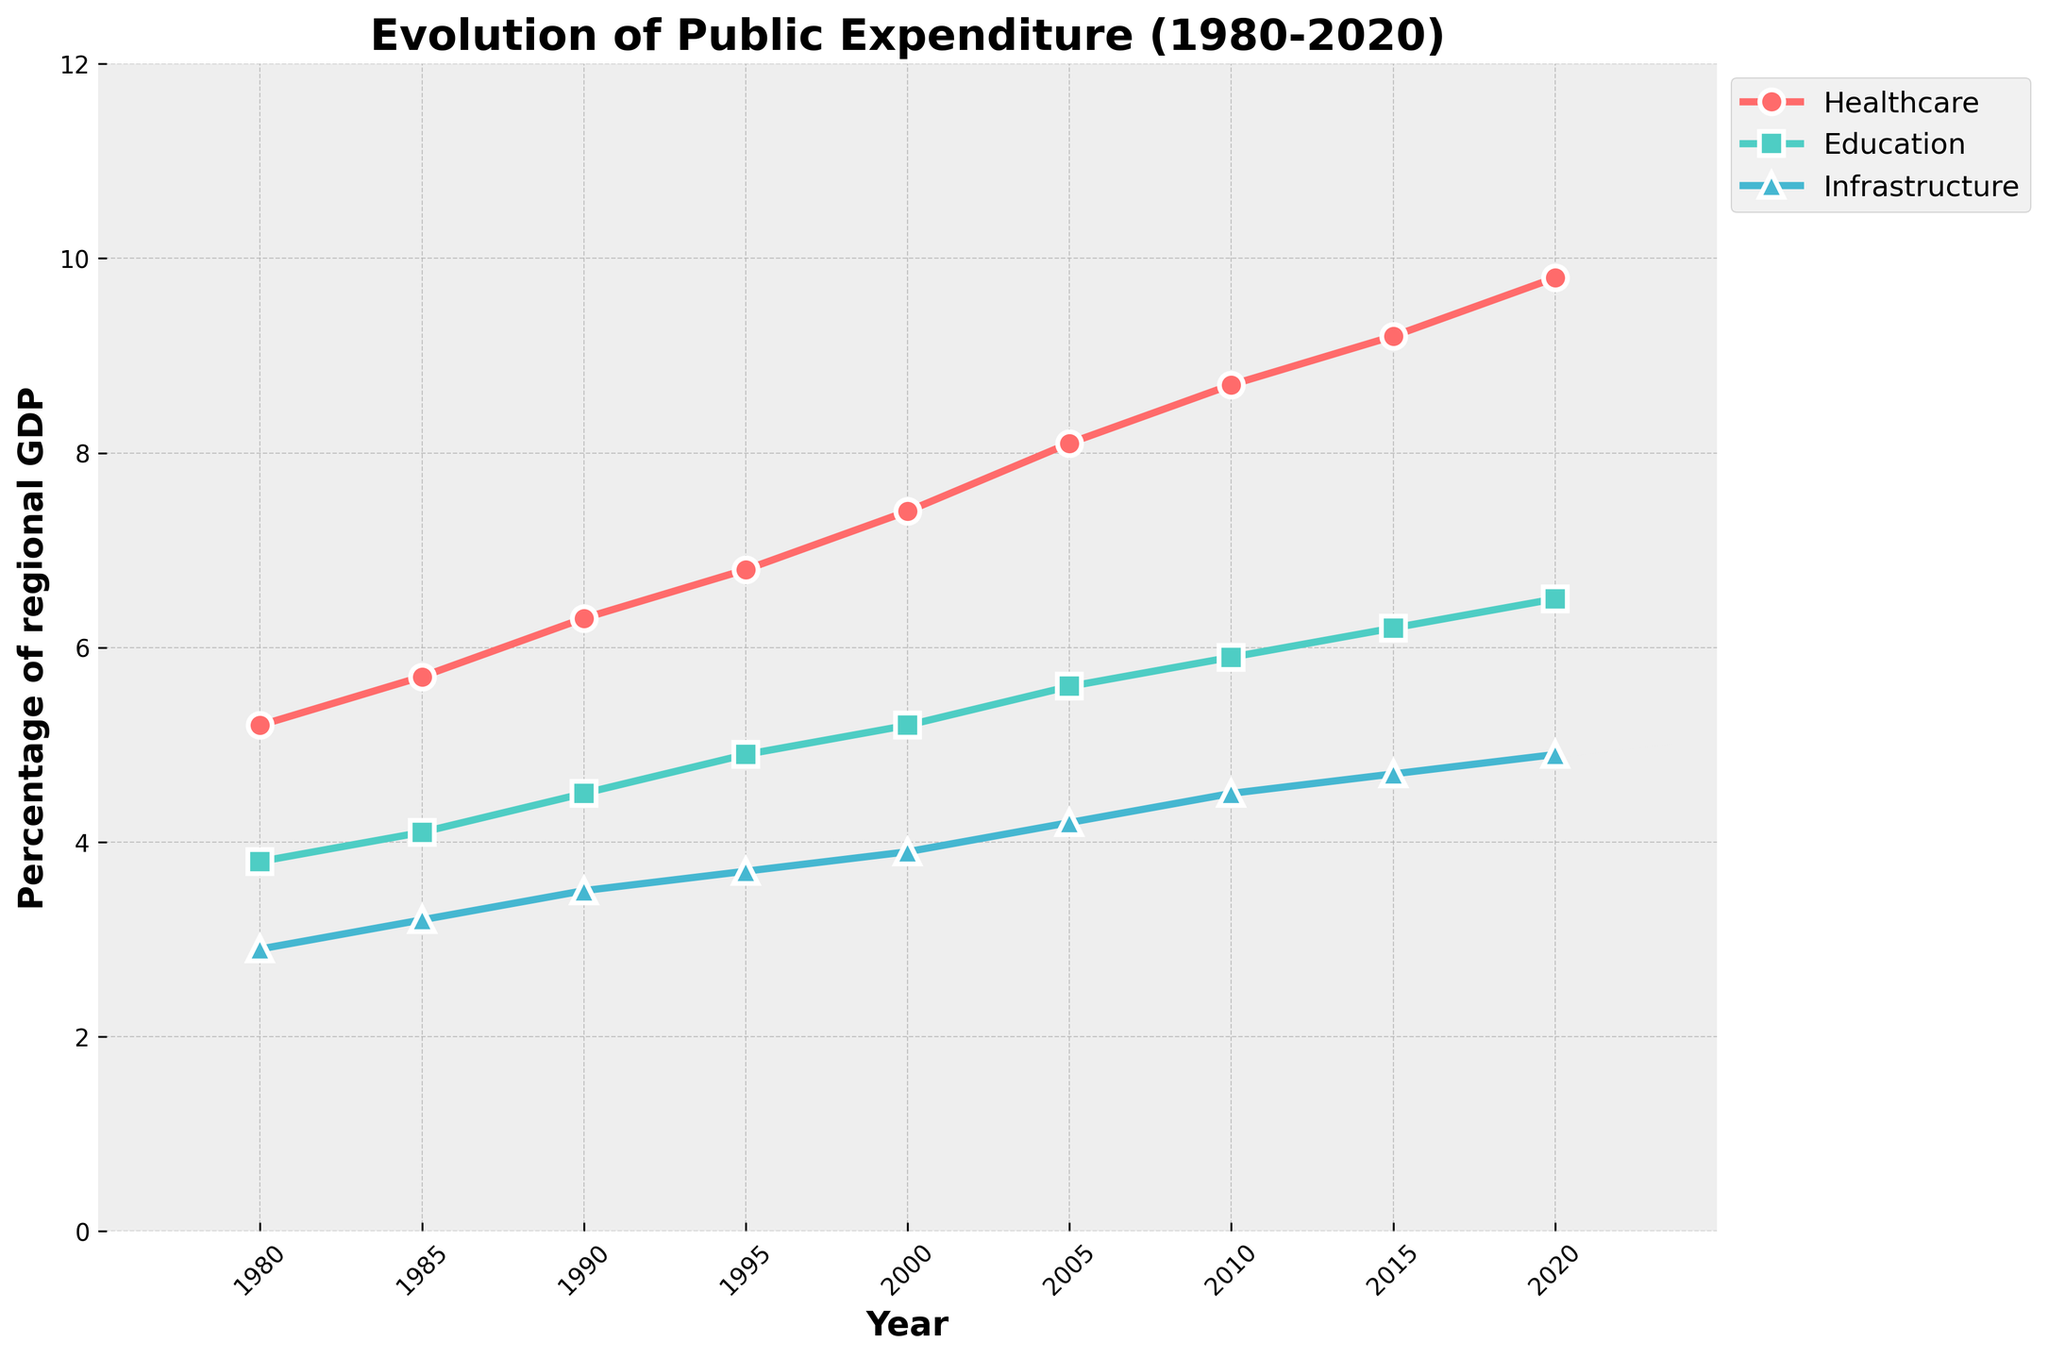what is the highest percentage of regional GDP spent on healthcare? The highest percentage of regional GDP spent on healthcare can be seen by identifying the peak of the healthcare line in the graph. Moving along the healthcare trend line, the highest percentage observed is in 2020, which is 9.8%.
Answer: 9.8% Which category had the smallest expenditure in 1980? To determine the smallest expenditure in 1980, compare the starting points for healthcare, education, and infrastructure. The healthcare line starts at 5.2%, education at 3.8%, and infrastructure at 2.9%. The smallest value is infrastructure at 2.9%.
Answer: Infrastructure Between which time periods did education expenditure see the greatest increase? Calculate the increase in education expenditure between each consecutive time period. The percentage changes are: 1980-1985 (0.3%), 1985-1990 (0.4%), 1990-1995 (0.4%), 1995-2000 (0.3%), 2000-2005 (0.4%), 2005-2010 (0.3%), 2010-2015 (0.3%), 2015-2020 (0.3%). The greatest increase of 0.4% occurred from 1985-1990 and again from 2000-2005.
Answer: 1985-1990 and 2000-2005 Is the trend for infrastructure expenditure growing faster, slower, or at the same rate as healthcare expenditure from 2000-2020? To assess the rates of change, calculate the total percentage increase from 2000 to 2020 for both healthcare and infrastructure. Healthcare rises from 7.4% to 9.8% (+2.4%), while infrastructure rises from 3.9% to 4.9% (+1.0%). The healthcare expenditure is growing faster than infrastructure expenditure.
Answer: Faster How does the public expenditure on education in 2010 compare to the healthcare expenditure in 1990? Compare the education percentage in 2010 (5.9%) with the healthcare expenditure in 1990 (6.3%). The education expenditure is slightly lower than the healthcare expenditure.
Answer: Lower What is the combined expenditure percentage on healthcare and education in 2005? Sum the expenditure percentages for healthcare (8.1%) and education (5.6%) in 2005. The combined expenditure is 8.1% + 5.6% = 13.7%.
Answer: 13.7% Did any category's expenditure as a percentage of GDP remain constant for two consecutive periods? Check if any category’s values stayed the same over two consecutive periods. All categories show a consistent increase over time without any constants.
Answer: No By how much did the expenditure on infrastructure change from 1980 to 2020? Subtract the infrastructure expenditure percentage in 1980 (2.9%) from that in 2020 (4.9%). The change is 4.9% - 2.9% = 2.0%.
Answer: 2.0% 